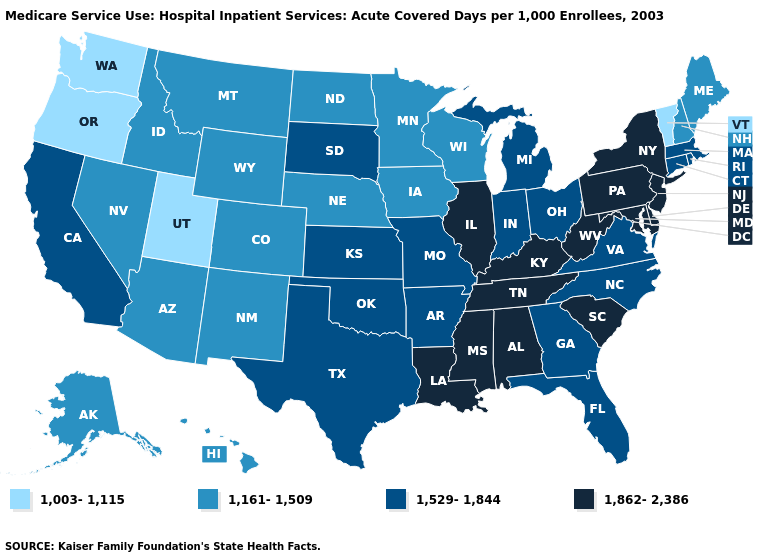Does Arizona have a higher value than Utah?
Quick response, please. Yes. What is the value of New Hampshire?
Quick response, please. 1,161-1,509. Name the states that have a value in the range 1,529-1,844?
Short answer required. Arkansas, California, Connecticut, Florida, Georgia, Indiana, Kansas, Massachusetts, Michigan, Missouri, North Carolina, Ohio, Oklahoma, Rhode Island, South Dakota, Texas, Virginia. Does Rhode Island have a higher value than Wisconsin?
Concise answer only. Yes. What is the highest value in the USA?
Short answer required. 1,862-2,386. Name the states that have a value in the range 1,862-2,386?
Short answer required. Alabama, Delaware, Illinois, Kentucky, Louisiana, Maryland, Mississippi, New Jersey, New York, Pennsylvania, South Carolina, Tennessee, West Virginia. Among the states that border Pennsylvania , which have the lowest value?
Quick response, please. Ohio. Among the states that border Georgia , which have the lowest value?
Write a very short answer. Florida, North Carolina. How many symbols are there in the legend?
Quick response, please. 4. Does Oregon have the lowest value in the USA?
Answer briefly. Yes. What is the value of Connecticut?
Answer briefly. 1,529-1,844. Does the map have missing data?
Concise answer only. No. Which states have the lowest value in the USA?
Short answer required. Oregon, Utah, Vermont, Washington. Does South Carolina have a lower value than New Mexico?
Quick response, please. No. Does New Mexico have the highest value in the West?
Quick response, please. No. 